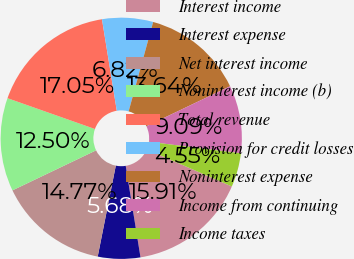Convert chart. <chart><loc_0><loc_0><loc_500><loc_500><pie_chart><fcel>Interest income<fcel>Interest expense<fcel>Net interest income<fcel>Noninterest income (b)<fcel>Total revenue<fcel>Provision for credit losses<fcel>Noninterest expense<fcel>Income from continuing<fcel>Income taxes<nl><fcel>15.91%<fcel>5.68%<fcel>14.77%<fcel>12.5%<fcel>17.05%<fcel>6.82%<fcel>13.64%<fcel>9.09%<fcel>4.55%<nl></chart> 